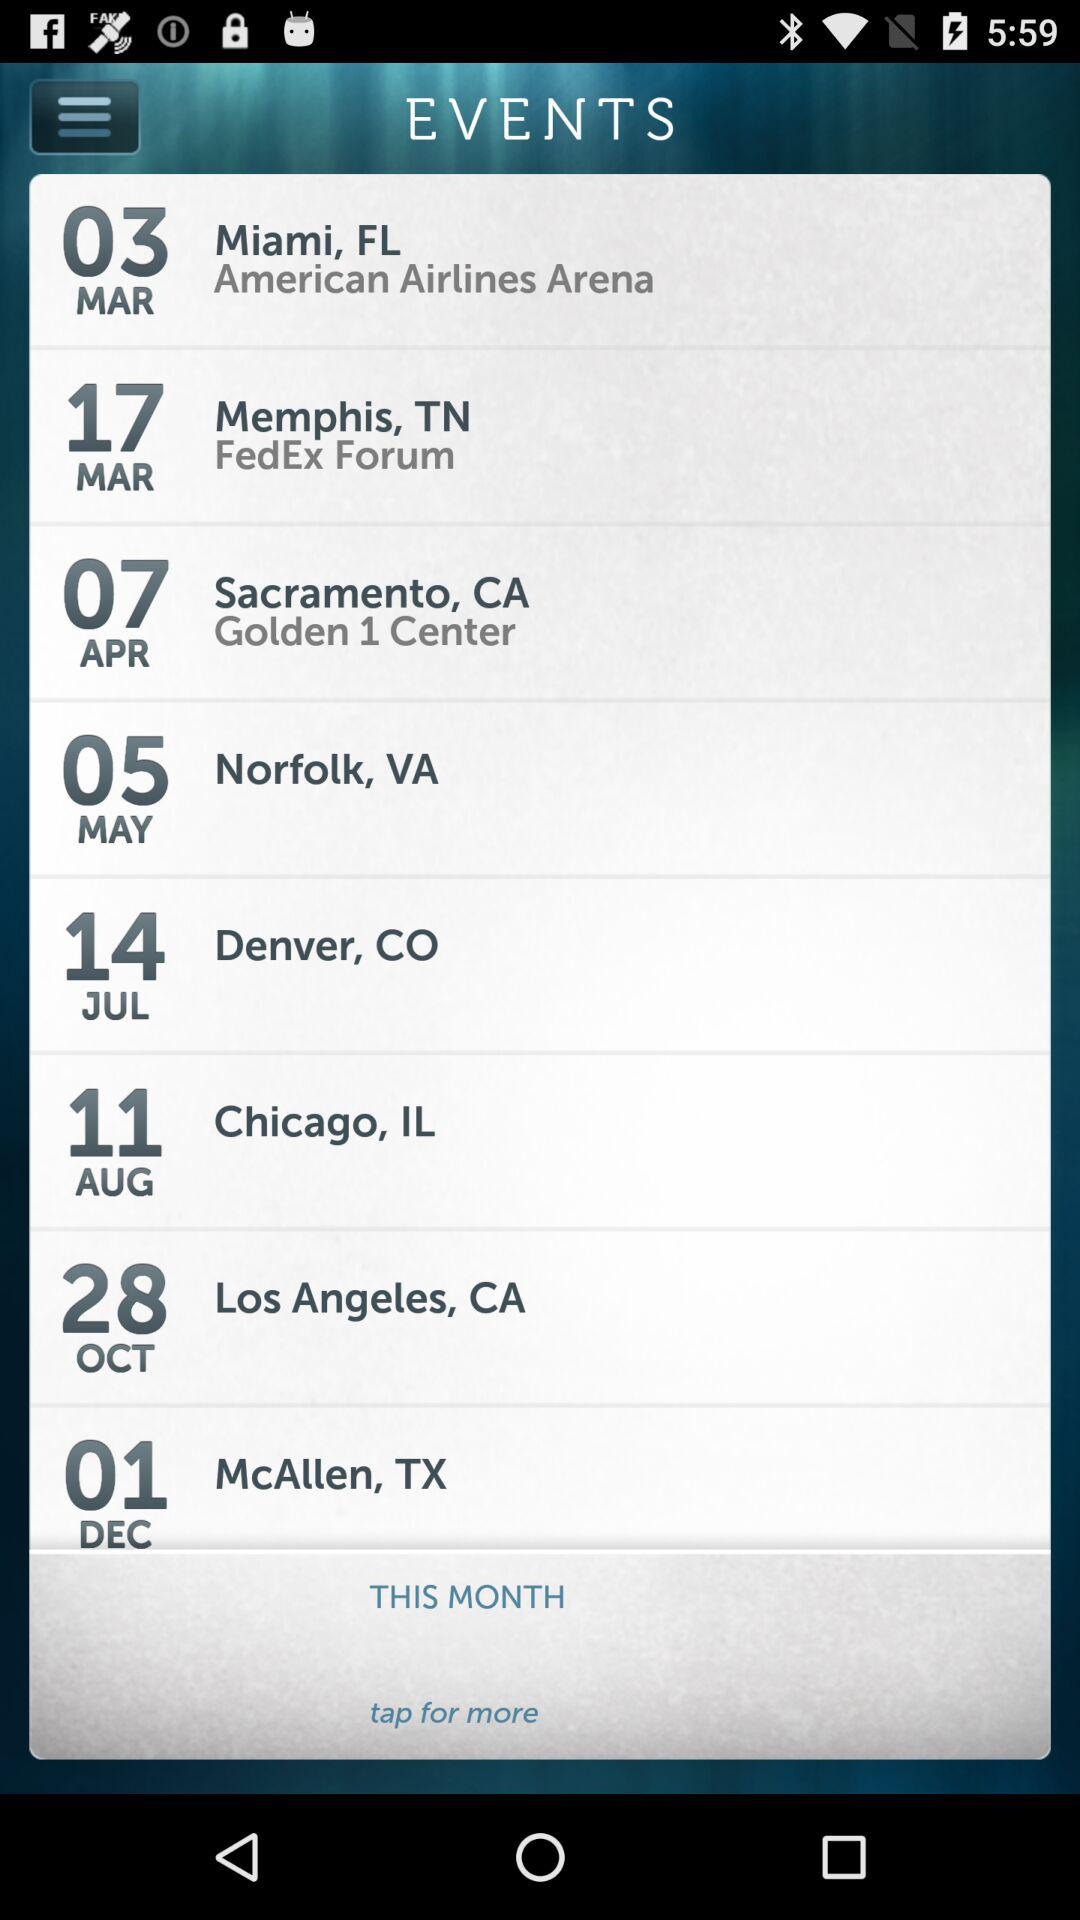Where is the event on April 7? The event is at "Golden 1 Center" in Sacramento, CA. 